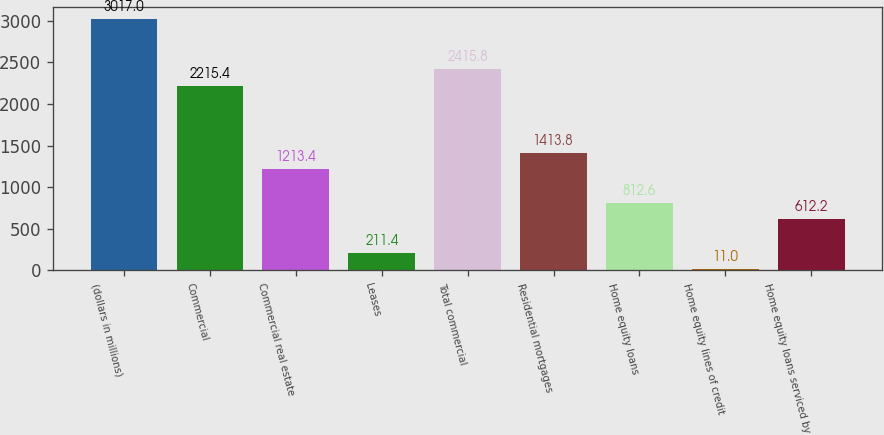<chart> <loc_0><loc_0><loc_500><loc_500><bar_chart><fcel>(dollars in millions)<fcel>Commercial<fcel>Commercial real estate<fcel>Leases<fcel>Total commercial<fcel>Residential mortgages<fcel>Home equity loans<fcel>Home equity lines of credit<fcel>Home equity loans serviced by<nl><fcel>3017<fcel>2215.4<fcel>1213.4<fcel>211.4<fcel>2415.8<fcel>1413.8<fcel>812.6<fcel>11<fcel>612.2<nl></chart> 